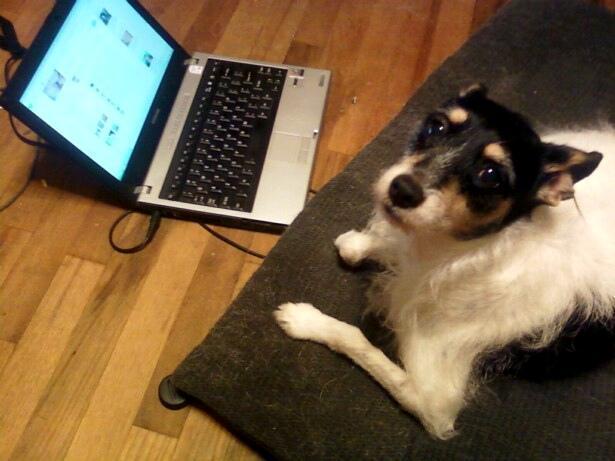How many cats?
Give a very brief answer. 0. How many monitors?
Give a very brief answer. 1. How many laptops are there?
Give a very brief answer. 1. How many people in the photo?
Give a very brief answer. 0. 